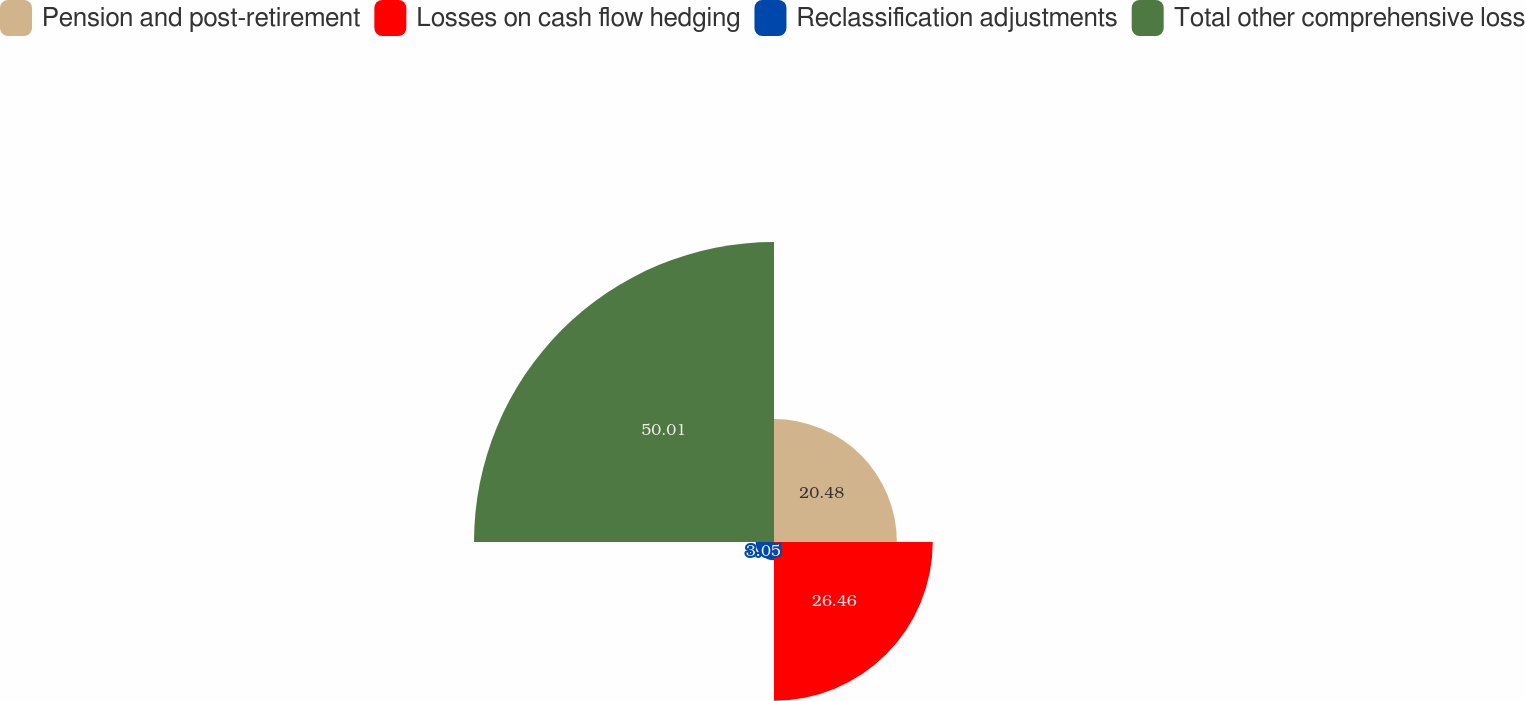<chart> <loc_0><loc_0><loc_500><loc_500><pie_chart><fcel>Pension and post-retirement<fcel>Losses on cash flow hedging<fcel>Reclassification adjustments<fcel>Total other comprehensive loss<nl><fcel>20.48%<fcel>26.46%<fcel>3.05%<fcel>50.0%<nl></chart> 